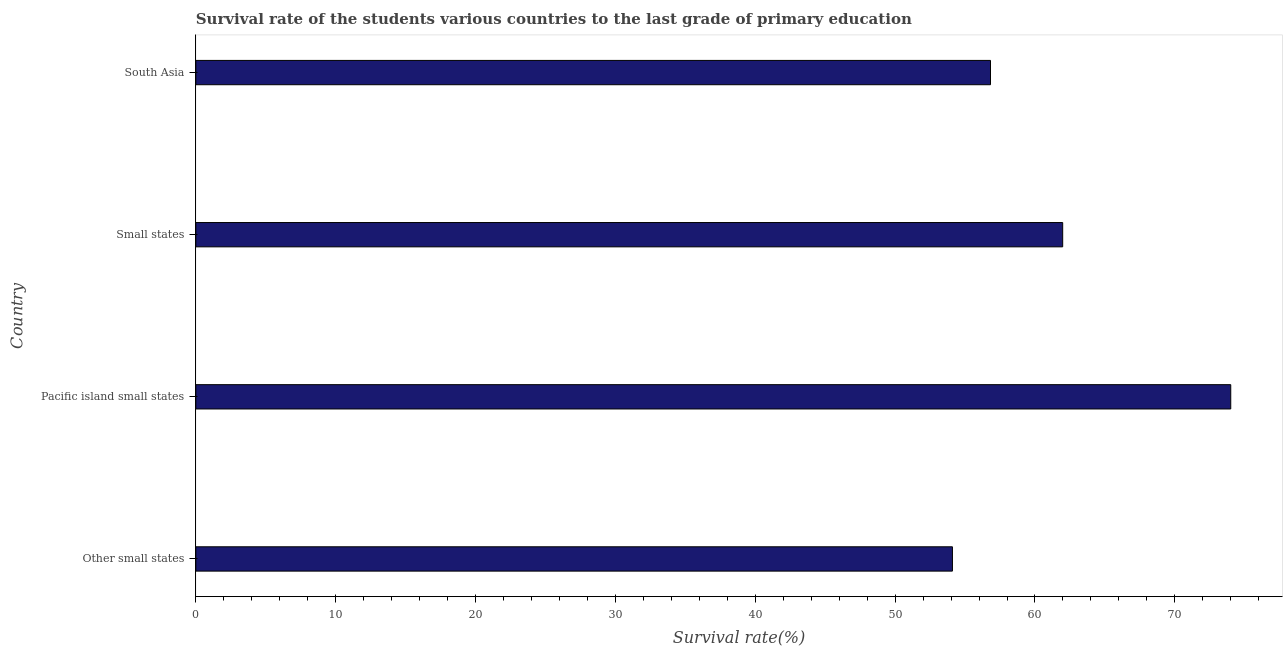Does the graph contain any zero values?
Your answer should be compact. No. Does the graph contain grids?
Offer a terse response. No. What is the title of the graph?
Offer a very short reply. Survival rate of the students various countries to the last grade of primary education. What is the label or title of the X-axis?
Provide a succinct answer. Survival rate(%). What is the label or title of the Y-axis?
Offer a terse response. Country. What is the survival rate in primary education in Other small states?
Ensure brevity in your answer.  54.1. Across all countries, what is the maximum survival rate in primary education?
Your response must be concise. 74. Across all countries, what is the minimum survival rate in primary education?
Provide a succinct answer. 54.1. In which country was the survival rate in primary education maximum?
Offer a very short reply. Pacific island small states. In which country was the survival rate in primary education minimum?
Provide a short and direct response. Other small states. What is the sum of the survival rate in primary education?
Ensure brevity in your answer.  246.9. What is the difference between the survival rate in primary education in Other small states and South Asia?
Give a very brief answer. -2.72. What is the average survival rate in primary education per country?
Your answer should be compact. 61.73. What is the median survival rate in primary education?
Provide a short and direct response. 59.4. In how many countries, is the survival rate in primary education greater than 8 %?
Your answer should be very brief. 4. What is the ratio of the survival rate in primary education in Other small states to that in Small states?
Offer a very short reply. 0.87. Is the difference between the survival rate in primary education in Small states and South Asia greater than the difference between any two countries?
Your answer should be very brief. No. What is the difference between the highest and the second highest survival rate in primary education?
Keep it short and to the point. 12.02. Is the sum of the survival rate in primary education in Other small states and Pacific island small states greater than the maximum survival rate in primary education across all countries?
Offer a very short reply. Yes. What is the difference between the highest and the lowest survival rate in primary education?
Your response must be concise. 19.9. In how many countries, is the survival rate in primary education greater than the average survival rate in primary education taken over all countries?
Your answer should be compact. 2. What is the Survival rate(%) in Other small states?
Offer a very short reply. 54.1. What is the Survival rate(%) in Pacific island small states?
Offer a terse response. 74. What is the Survival rate(%) of Small states?
Offer a very short reply. 61.98. What is the Survival rate(%) of South Asia?
Your answer should be very brief. 56.82. What is the difference between the Survival rate(%) in Other small states and Pacific island small states?
Your answer should be very brief. -19.9. What is the difference between the Survival rate(%) in Other small states and Small states?
Offer a terse response. -7.88. What is the difference between the Survival rate(%) in Other small states and South Asia?
Keep it short and to the point. -2.72. What is the difference between the Survival rate(%) in Pacific island small states and Small states?
Provide a short and direct response. 12.02. What is the difference between the Survival rate(%) in Pacific island small states and South Asia?
Provide a short and direct response. 17.18. What is the difference between the Survival rate(%) in Small states and South Asia?
Your answer should be very brief. 5.16. What is the ratio of the Survival rate(%) in Other small states to that in Pacific island small states?
Your answer should be compact. 0.73. What is the ratio of the Survival rate(%) in Other small states to that in Small states?
Give a very brief answer. 0.87. What is the ratio of the Survival rate(%) in Other small states to that in South Asia?
Your response must be concise. 0.95. What is the ratio of the Survival rate(%) in Pacific island small states to that in Small states?
Ensure brevity in your answer.  1.19. What is the ratio of the Survival rate(%) in Pacific island small states to that in South Asia?
Keep it short and to the point. 1.3. What is the ratio of the Survival rate(%) in Small states to that in South Asia?
Give a very brief answer. 1.09. 